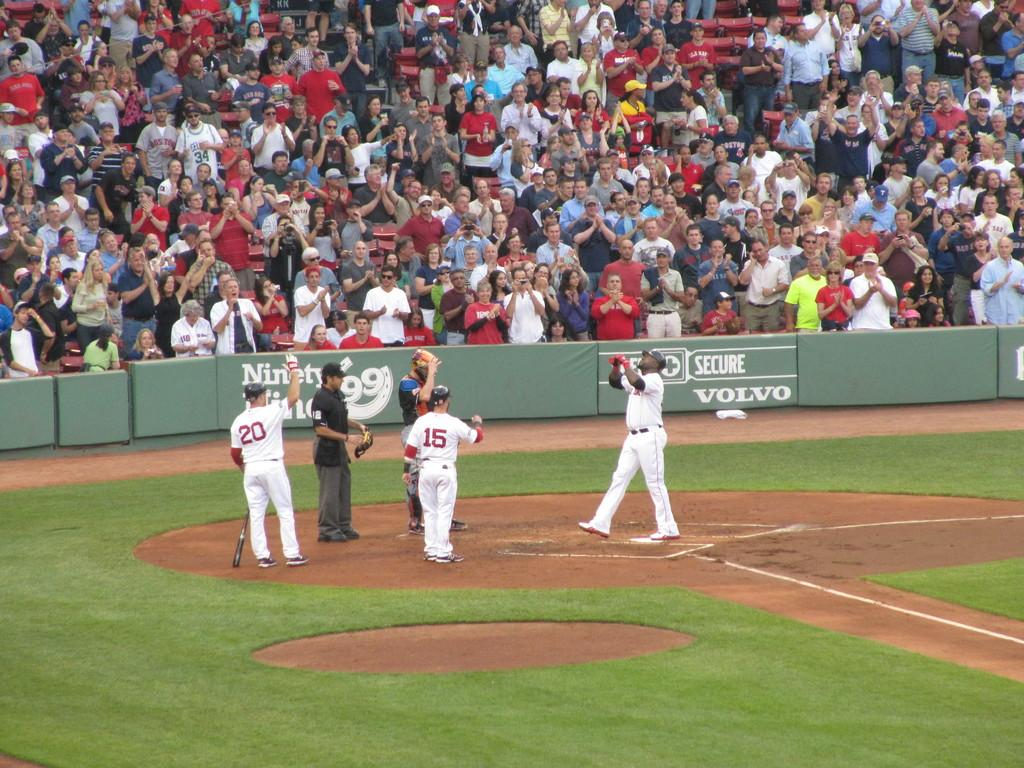<image>
Render a clear and concise summary of the photo. Players 20 and 15 greet their teammate at the plate. 